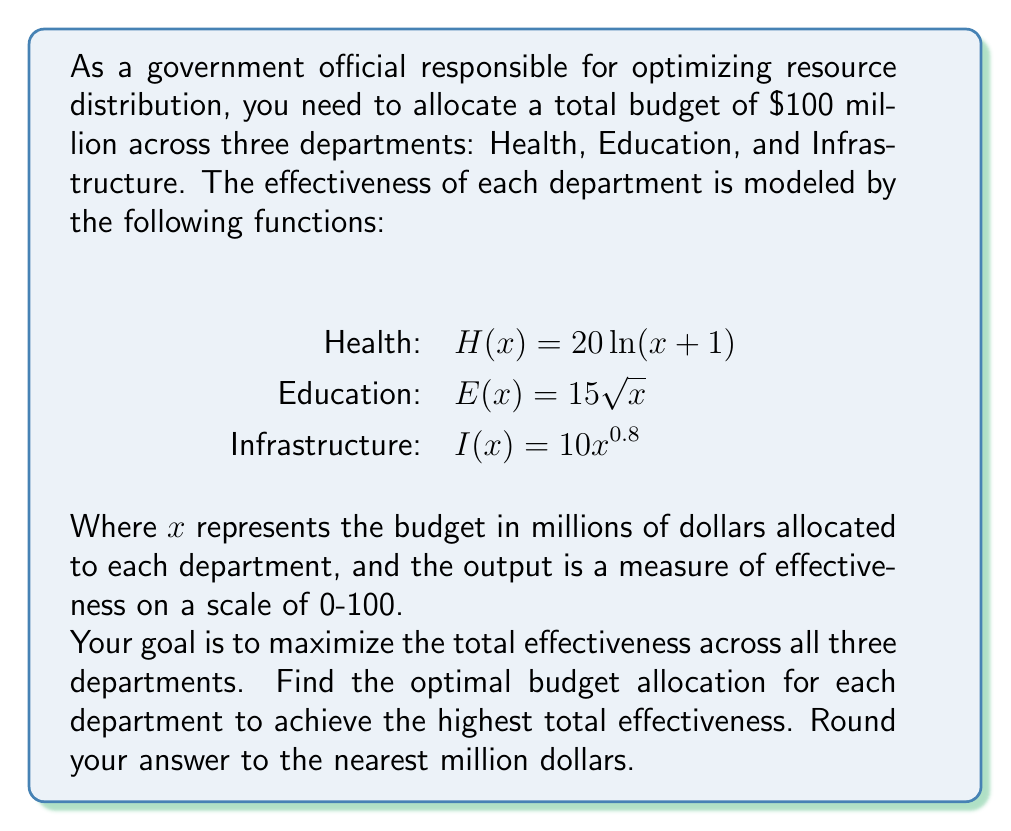Teach me how to tackle this problem. To solve this optimization problem, we need to use the method of Lagrange multipliers, as we have a constraint (total budget) and want to maximize the sum of three functions.

1) Let's define our objective function:
   $$f(x,y,z) = 20\ln(x+1) + 15\sqrt{y} + 10z^{0.8}$$

2) Our constraint is:
   $$g(x,y,z) = x + y + z - 100 = 0$$

3) According to the method of Lagrange multipliers, at the optimal point, the gradients of $f$ and $g$ should be parallel:

   $$\nabla f = \lambda \nabla g$$

4) This gives us the following system of equations:

   $$\frac{20}{x+1} = \lambda$$
   $$\frac{15}{2\sqrt{y}} = \lambda$$
   $$8z^{-0.2} = \lambda$$
   $$x + y + z = 100$$

5) From the first three equations, we can express x, y, and z in terms of λ:

   $$x = \frac{20}{\lambda} - 1$$
   $$y = \frac{225}{4\lambda^2}$$
   $$z = (\frac{8}{\lambda})^5$$

6) Substituting these into the fourth equation:

   $$\frac{20}{\lambda} - 1 + \frac{225}{4\lambda^2} + (\frac{8}{\lambda})^5 = 100$$

7) This equation can be solved numerically. Using a computational tool, we find:

   $$\lambda \approx 0.3947$$

8) Substituting this value back into our expressions for x, y, and z:

   $$x \approx 49.64$$
   $$y \approx 36.11$$
   $$z \approx 14.25$$

9) Rounding to the nearest million:

   Health (x): $50 million
   Education (y): $36 million
   Infrastructure (z): $14 million
Answer: The optimal budget allocation (rounded to the nearest million dollars) is:
Health: $50 million
Education: $36 million
Infrastructure: $14 million 